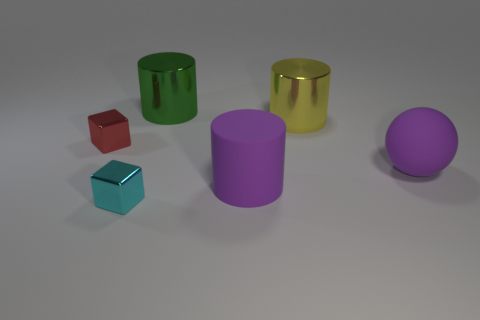Add 2 purple balls. How many objects exist? 8 Subtract all spheres. How many objects are left? 5 Subtract all matte spheres. Subtract all yellow metal objects. How many objects are left? 4 Add 3 yellow metallic cylinders. How many yellow metallic cylinders are left? 4 Add 3 small metallic spheres. How many small metallic spheres exist? 3 Subtract 0 blue cylinders. How many objects are left? 6 